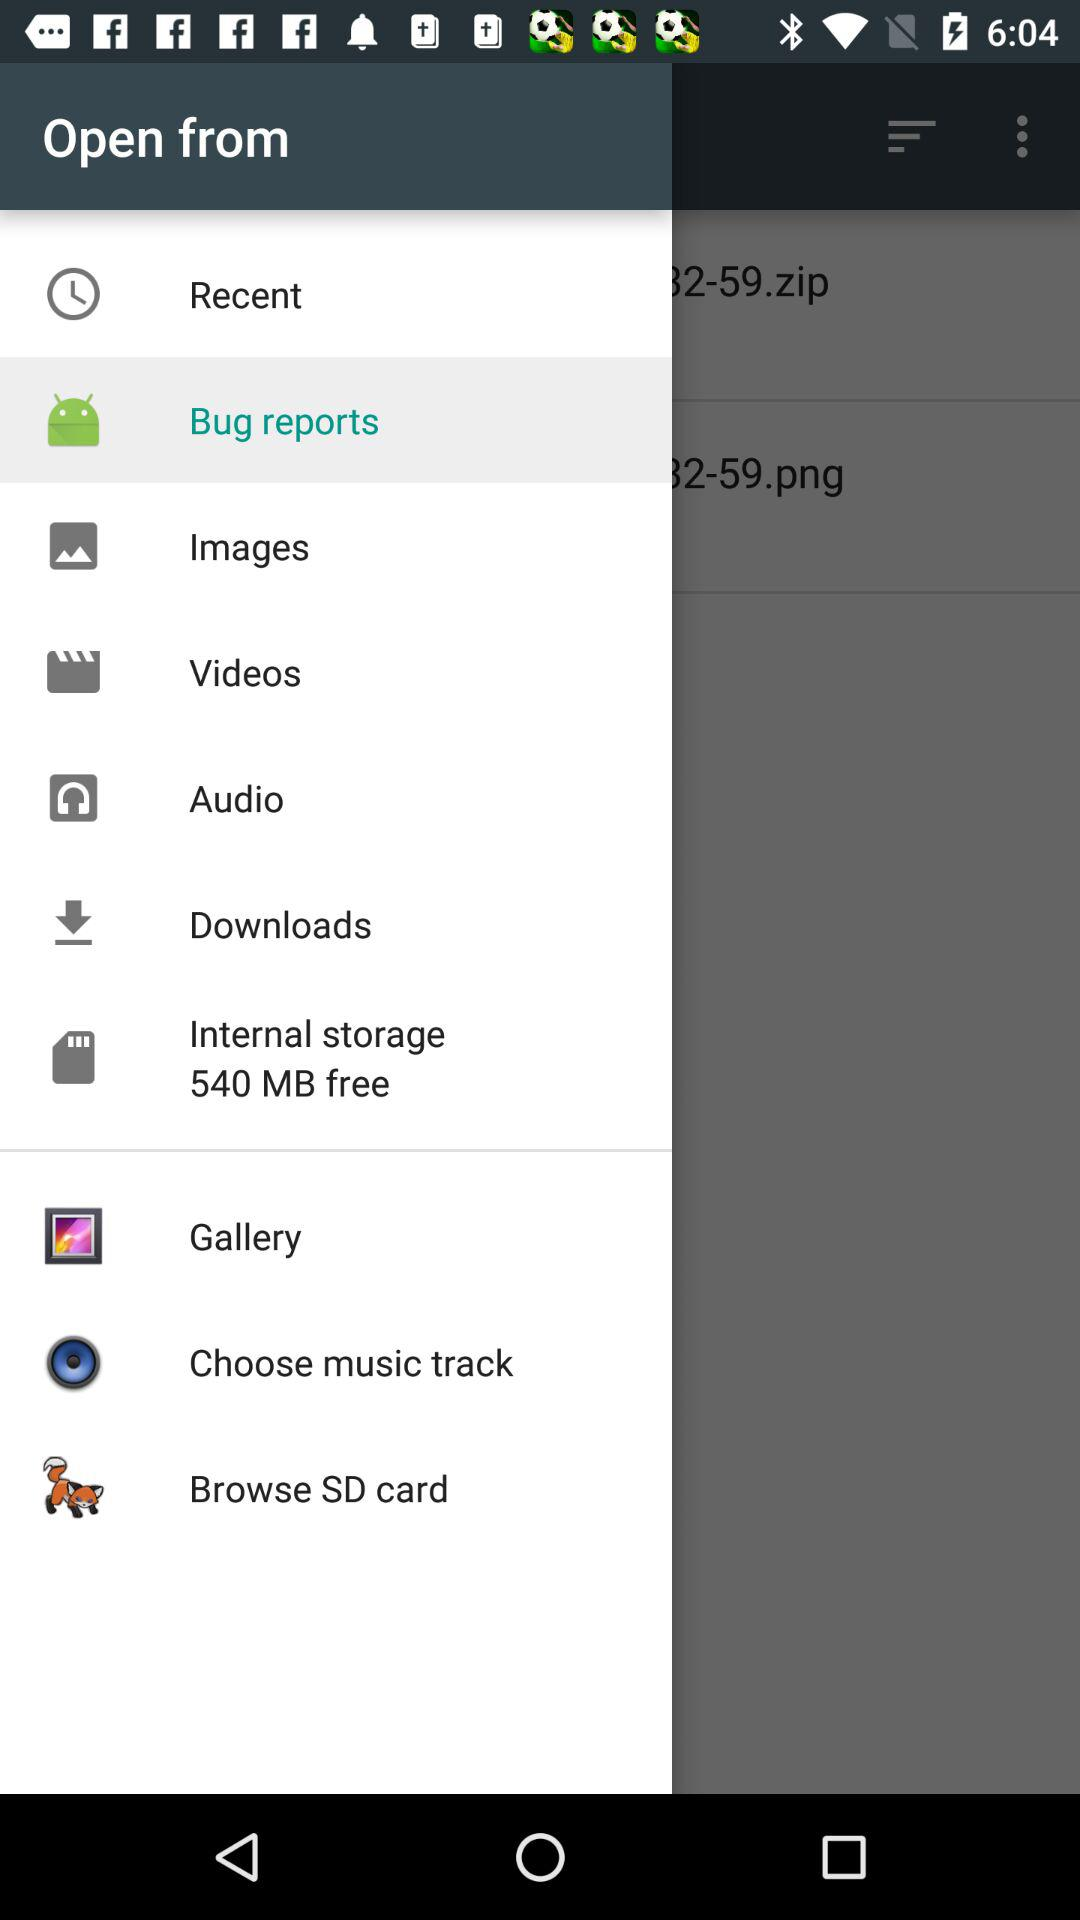How many MBs of storage space are free on the device?
Answer the question using a single word or phrase. 540 